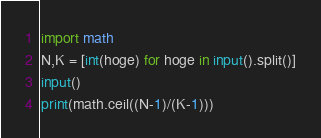<code> <loc_0><loc_0><loc_500><loc_500><_Python_>import math
N,K = [int(hoge) for hoge in input().split()]
input()
print(math.ceil((N-1)/(K-1)))</code> 